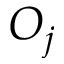Convert formula to latex. <formula><loc_0><loc_0><loc_500><loc_500>O _ { j }</formula> 